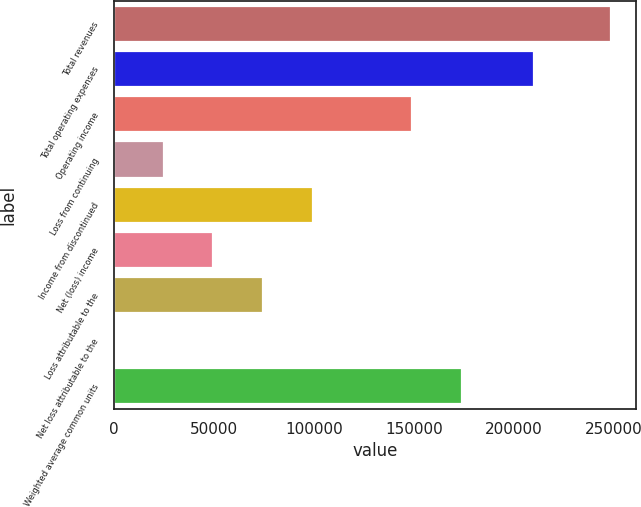<chart> <loc_0><loc_0><loc_500><loc_500><bar_chart><fcel>Total revenues<fcel>Total operating expenses<fcel>Operating income<fcel>Loss from continuing<fcel>Income from discontinued<fcel>Net (loss) income<fcel>Loss attributable to the<fcel>Net loss attributable to the<fcel>Weighted average common units<nl><fcel>248452<fcel>209822<fcel>149071<fcel>24845.4<fcel>99380.9<fcel>49690.6<fcel>74535.7<fcel>0.19<fcel>173916<nl></chart> 